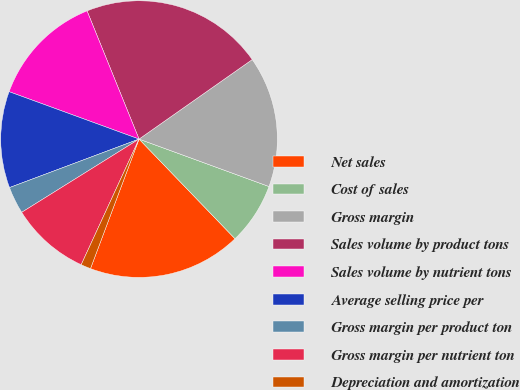Convert chart to OTSL. <chart><loc_0><loc_0><loc_500><loc_500><pie_chart><fcel>Net sales<fcel>Cost of sales<fcel>Gross margin<fcel>Sales volume by product tons<fcel>Sales volume by nutrient tons<fcel>Average selling price per<fcel>Gross margin per product ton<fcel>Gross margin per nutrient ton<fcel>Depreciation and amortization<nl><fcel>17.91%<fcel>7.23%<fcel>15.32%<fcel>21.39%<fcel>13.3%<fcel>11.27%<fcel>3.18%<fcel>9.25%<fcel>1.16%<nl></chart> 